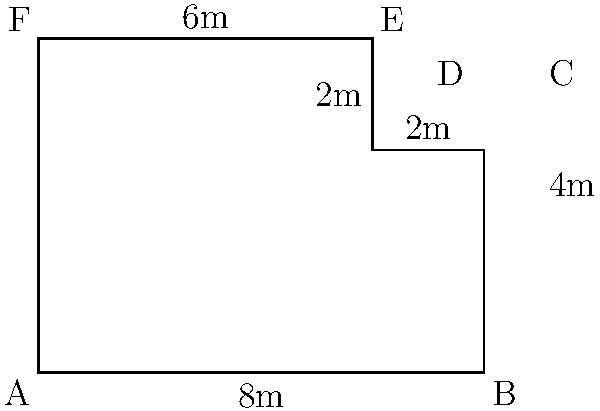As a method actor, you're preparing for a role in a play with a uniquely shaped stage. The director hands you a floor plan of the polygonal stage, as shown in the diagram. Calculate the total area of the stage floor in square meters, adhering strictly to the given dimensions without any improvisations. Let's approach this step-by-step, following the script (given dimensions) precisely:

1) The stage can be divided into two rectangles: ABCF and CDEF.

2) For rectangle ABCF:
   Length = 8m
   Width = 4m
   Area of ABCF = $8 \times 4 = 32$ sq m

3) For rectangle CDEF:
   Length = 2m
   Width = 2m
   Area of CDEF = $2 \times 2 = 4$ sq m

4) Total area of the stage:
   Total Area = Area of ABCF + Area of CDEF
               $= 32 + 4 = 36$ sq m

Therefore, adhering strictly to the given dimensions, the total area of the stage floor is 36 square meters.
Answer: 36 sq m 